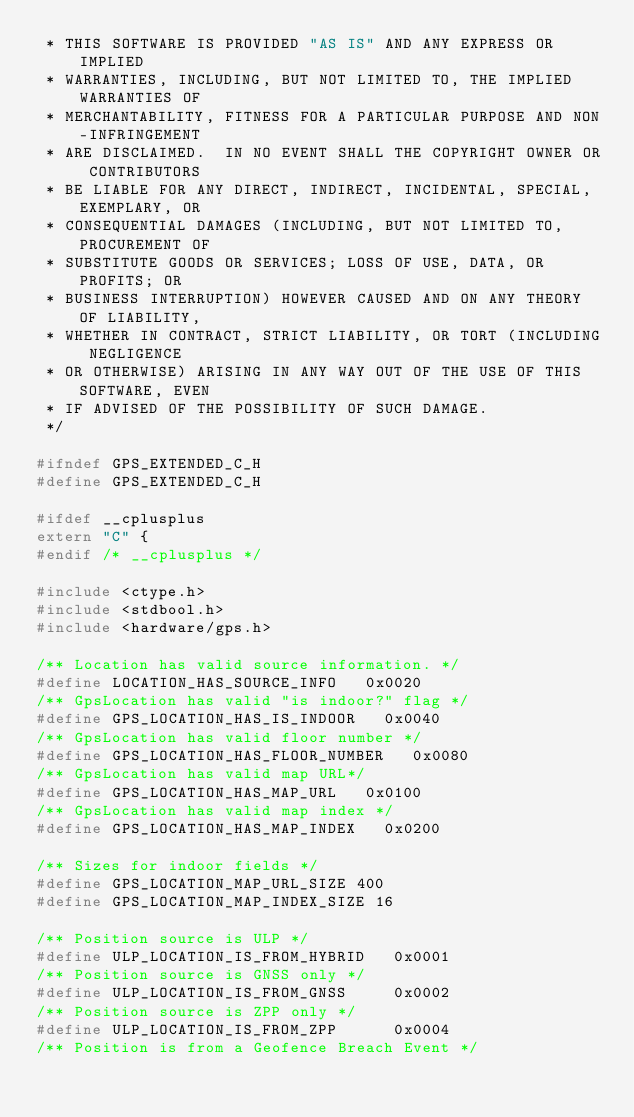<code> <loc_0><loc_0><loc_500><loc_500><_C_> * THIS SOFTWARE IS PROVIDED "AS IS" AND ANY EXPRESS OR IMPLIED
 * WARRANTIES, INCLUDING, BUT NOT LIMITED TO, THE IMPLIED WARRANTIES OF
 * MERCHANTABILITY, FITNESS FOR A PARTICULAR PURPOSE AND NON-INFRINGEMENT
 * ARE DISCLAIMED.  IN NO EVENT SHALL THE COPYRIGHT OWNER OR CONTRIBUTORS
 * BE LIABLE FOR ANY DIRECT, INDIRECT, INCIDENTAL, SPECIAL, EXEMPLARY, OR
 * CONSEQUENTIAL DAMAGES (INCLUDING, BUT NOT LIMITED TO, PROCUREMENT OF
 * SUBSTITUTE GOODS OR SERVICES; LOSS OF USE, DATA, OR PROFITS; OR
 * BUSINESS INTERRUPTION) HOWEVER CAUSED AND ON ANY THEORY OF LIABILITY,
 * WHETHER IN CONTRACT, STRICT LIABILITY, OR TORT (INCLUDING NEGLIGENCE
 * OR OTHERWISE) ARISING IN ANY WAY OUT OF THE USE OF THIS SOFTWARE, EVEN
 * IF ADVISED OF THE POSSIBILITY OF SUCH DAMAGE.
 */

#ifndef GPS_EXTENDED_C_H
#define GPS_EXTENDED_C_H

#ifdef __cplusplus
extern "C" {
#endif /* __cplusplus */

#include <ctype.h>
#include <stdbool.h>
#include <hardware/gps.h>

/** Location has valid source information. */
#define LOCATION_HAS_SOURCE_INFO   0x0020
/** GpsLocation has valid "is indoor?" flag */
#define GPS_LOCATION_HAS_IS_INDOOR   0x0040
/** GpsLocation has valid floor number */
#define GPS_LOCATION_HAS_FLOOR_NUMBER   0x0080
/** GpsLocation has valid map URL*/
#define GPS_LOCATION_HAS_MAP_URL   0x0100
/** GpsLocation has valid map index */
#define GPS_LOCATION_HAS_MAP_INDEX   0x0200

/** Sizes for indoor fields */
#define GPS_LOCATION_MAP_URL_SIZE 400
#define GPS_LOCATION_MAP_INDEX_SIZE 16

/** Position source is ULP */
#define ULP_LOCATION_IS_FROM_HYBRID   0x0001
/** Position source is GNSS only */
#define ULP_LOCATION_IS_FROM_GNSS     0x0002
/** Position source is ZPP only */
#define ULP_LOCATION_IS_FROM_ZPP      0x0004
/** Position is from a Geofence Breach Event */</code> 